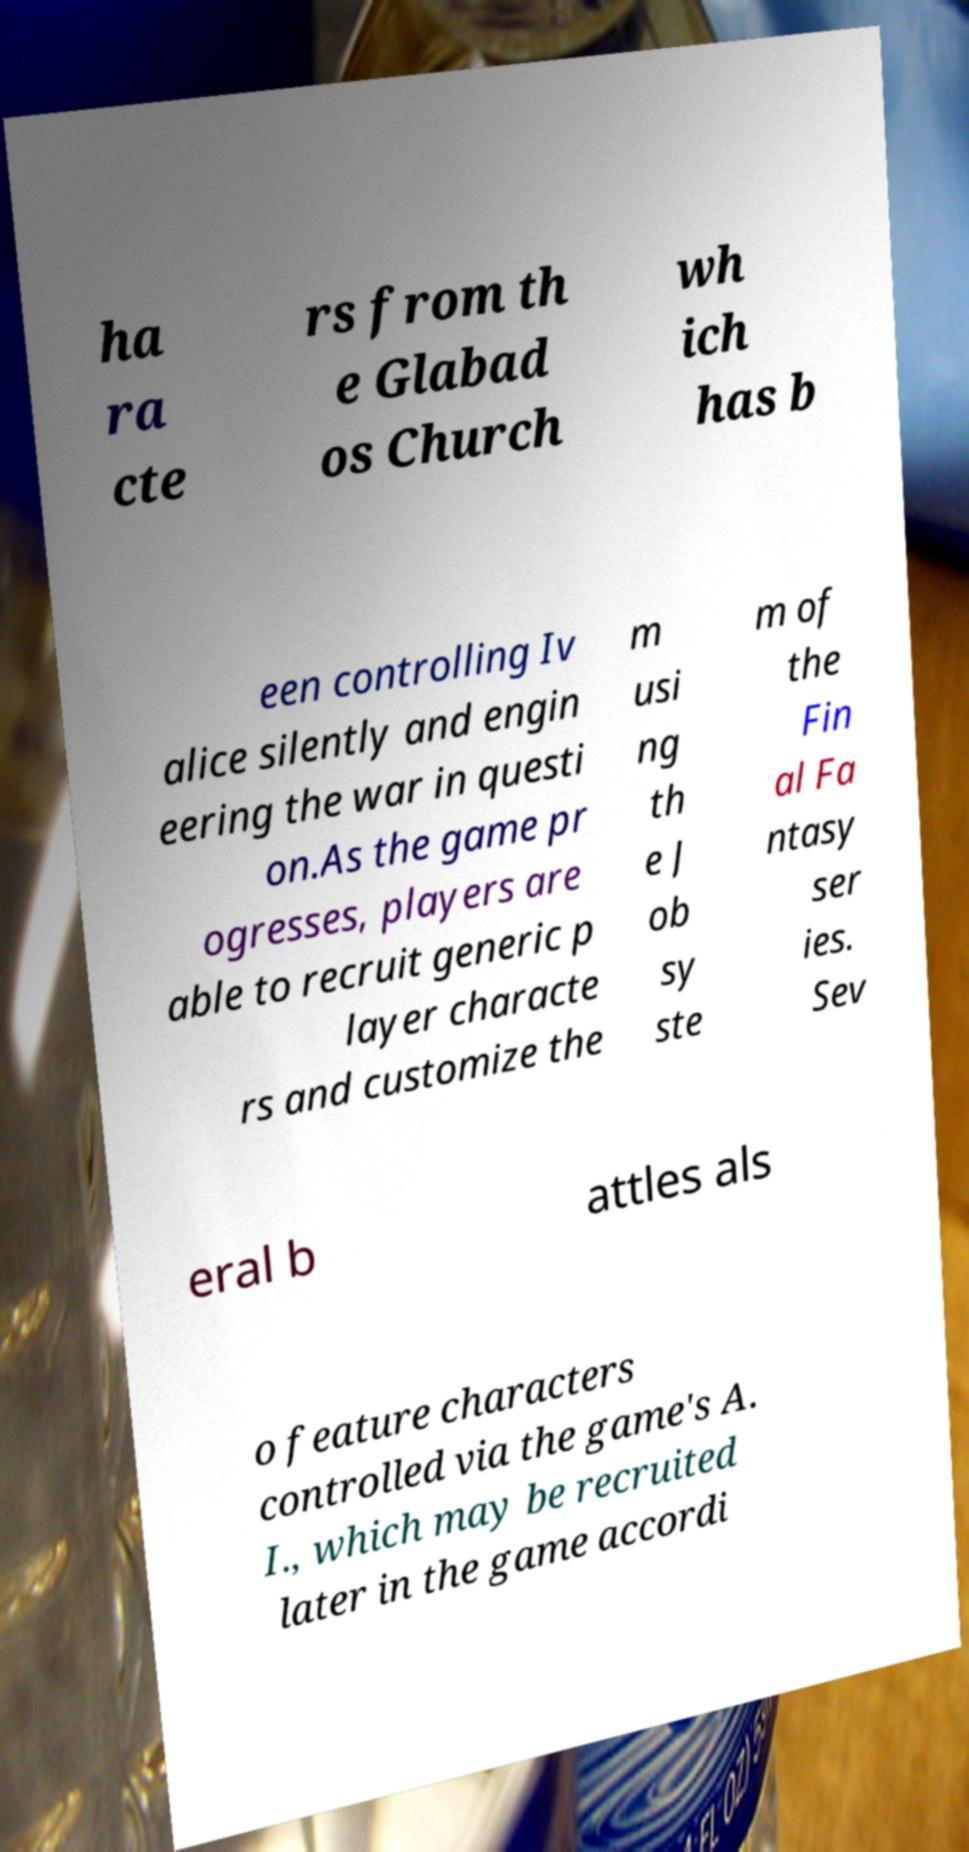Please read and relay the text visible in this image. What does it say? ha ra cte rs from th e Glabad os Church wh ich has b een controlling Iv alice silently and engin eering the war in questi on.As the game pr ogresses, players are able to recruit generic p layer characte rs and customize the m usi ng th e J ob sy ste m of the Fin al Fa ntasy ser ies. Sev eral b attles als o feature characters controlled via the game's A. I., which may be recruited later in the game accordi 